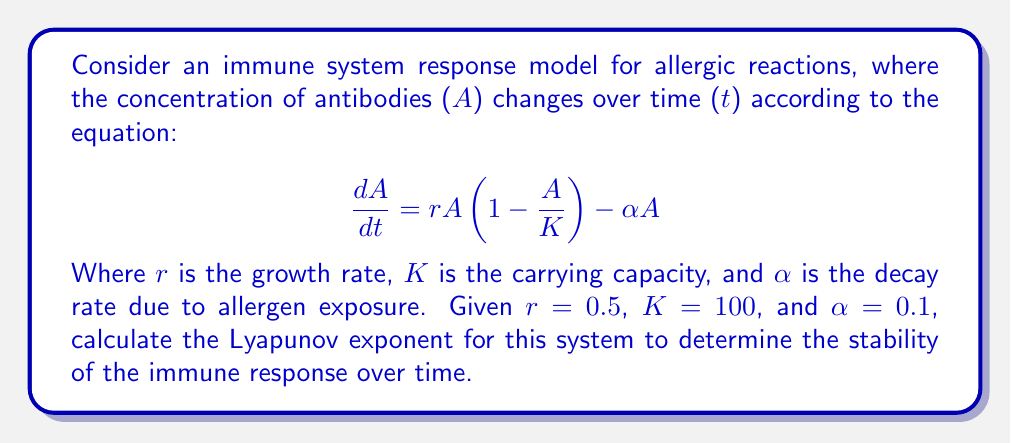Help me with this question. To determine the Lyapunov exponent for this immune system response model, we'll follow these steps:

1. Find the fixed points of the system:
   Set $\frac{dA}{dt} = 0$ and solve for A:
   $$0 = rA(1 - \frac{A}{K}) - \alpha A$$
   $$0 = 0.5A(1 - \frac{A}{100}) - 0.1A$$
   $$0 = 0.5A - 0.005A^2 - 0.1A$$
   $$0 = 0.4A - 0.005A^2$$
   $$A(0.4 - 0.005A) = 0$$
   $$A = 0$$ or $$A = 80$$

2. Calculate the derivative of the function with respect to A:
   $$\frac{d}{dA}(\frac{dA}{dt}) = r(1 - \frac{2A}{K}) - \alpha$$
   $$\frac{d}{dA}(\frac{dA}{dt}) = 0.5(1 - \frac{2A}{100}) - 0.1$$
   $$\frac{d}{dA}(\frac{dA}{dt}) = 0.5 - 0.01A - 0.1$$
   $$\frac{d}{dA}(\frac{dA}{dt}) = 0.4 - 0.01A$$

3. Evaluate the derivative at the non-zero fixed point (A = 80):
   $$\lambda = 0.4 - 0.01(80) = 0.4 - 0.8 = -0.4$$

4. The Lyapunov exponent is the value of λ calculated in step 3.

Since the Lyapunov exponent is negative (-0.4), this indicates that the system is stable and will converge to the fixed point over time. For a cautious parent managing a child's allergies, this suggests that the immune system's response to allergens will tend to stabilize, helping to maintain a consistent level of antibodies to combat allergic reactions.
Answer: $\lambda = -0.4$ 